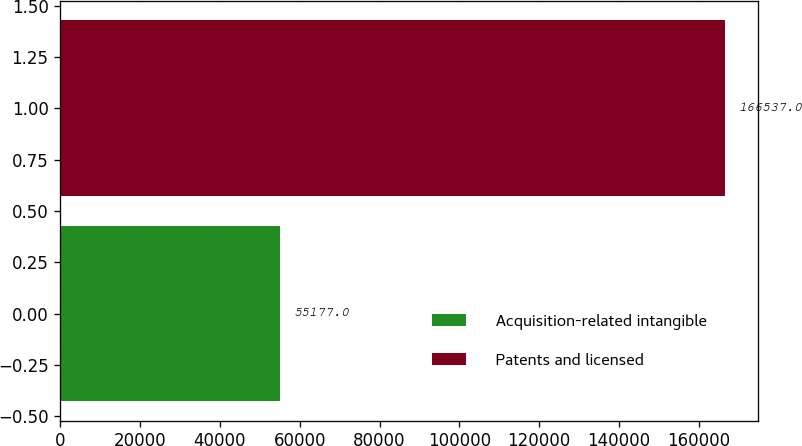<chart> <loc_0><loc_0><loc_500><loc_500><bar_chart><fcel>Acquisition-related intangible<fcel>Patents and licensed<nl><fcel>55177<fcel>166537<nl></chart> 